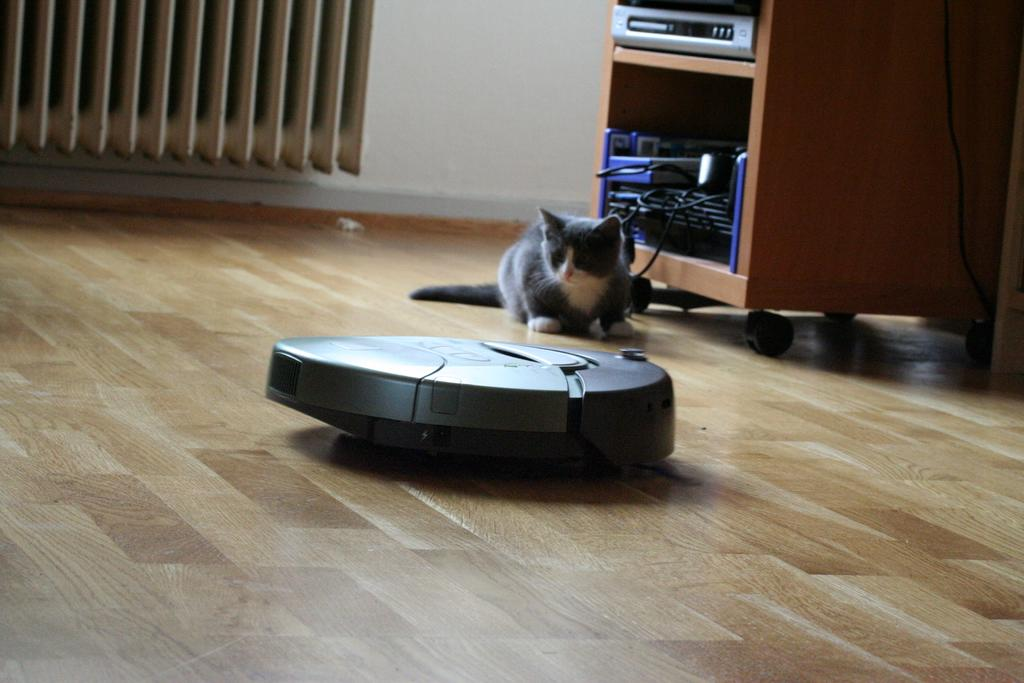What animal is on the floor in the image? There is a cat on the floor in the image. What other object is on the floor in the image? There is a vacuum robot on the floor in the image. What type of furniture is in the image? There is a cupboard in the image. What device is inside the cupboard? The cupboard has a disc player in it. What can be seen on the walls in the background of the image? The background of the image includes walls. What type of yarn is the cat using to connect to the vacuum robot in the image? There is no yarn or connection between the cat and the vacuum robot in the image; they are separate entities. 